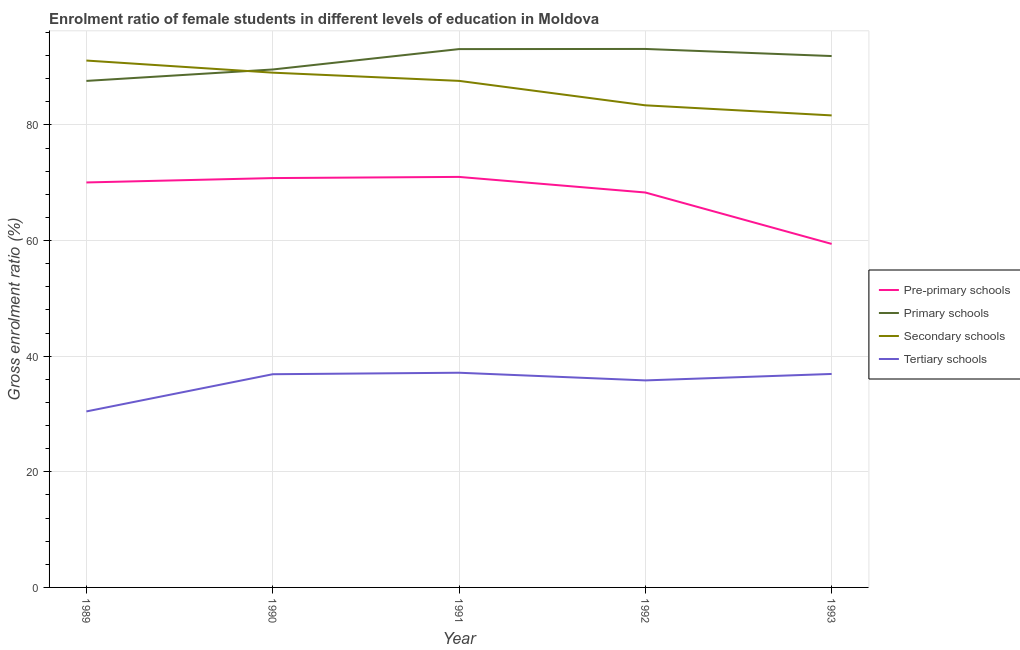How many different coloured lines are there?
Your answer should be compact. 4. Does the line corresponding to gross enrolment ratio(male) in secondary schools intersect with the line corresponding to gross enrolment ratio(male) in tertiary schools?
Offer a very short reply. No. What is the gross enrolment ratio(male) in tertiary schools in 1990?
Ensure brevity in your answer.  36.88. Across all years, what is the maximum gross enrolment ratio(male) in tertiary schools?
Keep it short and to the point. 37.13. Across all years, what is the minimum gross enrolment ratio(male) in secondary schools?
Keep it short and to the point. 81.64. What is the total gross enrolment ratio(male) in secondary schools in the graph?
Your response must be concise. 432.82. What is the difference between the gross enrolment ratio(male) in pre-primary schools in 1989 and that in 1992?
Make the answer very short. 1.74. What is the difference between the gross enrolment ratio(male) in tertiary schools in 1989 and the gross enrolment ratio(male) in secondary schools in 1990?
Your answer should be very brief. -58.6. What is the average gross enrolment ratio(male) in pre-primary schools per year?
Your response must be concise. 67.92. In the year 1992, what is the difference between the gross enrolment ratio(male) in secondary schools and gross enrolment ratio(male) in tertiary schools?
Your response must be concise. 47.58. In how many years, is the gross enrolment ratio(male) in secondary schools greater than 36 %?
Your response must be concise. 5. What is the ratio of the gross enrolment ratio(male) in tertiary schools in 1992 to that in 1993?
Your answer should be very brief. 0.97. Is the gross enrolment ratio(male) in primary schools in 1990 less than that in 1992?
Keep it short and to the point. Yes. Is the difference between the gross enrolment ratio(male) in secondary schools in 1991 and 1993 greater than the difference between the gross enrolment ratio(male) in tertiary schools in 1991 and 1993?
Ensure brevity in your answer.  Yes. What is the difference between the highest and the second highest gross enrolment ratio(male) in secondary schools?
Your answer should be very brief. 2.09. What is the difference between the highest and the lowest gross enrolment ratio(male) in tertiary schools?
Your response must be concise. 6.69. In how many years, is the gross enrolment ratio(male) in tertiary schools greater than the average gross enrolment ratio(male) in tertiary schools taken over all years?
Your answer should be compact. 4. Is it the case that in every year, the sum of the gross enrolment ratio(male) in pre-primary schools and gross enrolment ratio(male) in primary schools is greater than the sum of gross enrolment ratio(male) in secondary schools and gross enrolment ratio(male) in tertiary schools?
Give a very brief answer. Yes. Does the gross enrolment ratio(male) in tertiary schools monotonically increase over the years?
Ensure brevity in your answer.  No. Does the graph contain grids?
Provide a succinct answer. Yes. Where does the legend appear in the graph?
Ensure brevity in your answer.  Center right. How many legend labels are there?
Give a very brief answer. 4. How are the legend labels stacked?
Your answer should be very brief. Vertical. What is the title of the graph?
Offer a very short reply. Enrolment ratio of female students in different levels of education in Moldova. What is the label or title of the X-axis?
Your response must be concise. Year. What is the label or title of the Y-axis?
Give a very brief answer. Gross enrolment ratio (%). What is the Gross enrolment ratio (%) of Pre-primary schools in 1989?
Your response must be concise. 70.05. What is the Gross enrolment ratio (%) in Primary schools in 1989?
Make the answer very short. 87.61. What is the Gross enrolment ratio (%) of Secondary schools in 1989?
Give a very brief answer. 91.13. What is the Gross enrolment ratio (%) in Tertiary schools in 1989?
Offer a very short reply. 30.44. What is the Gross enrolment ratio (%) of Pre-primary schools in 1990?
Your answer should be very brief. 70.8. What is the Gross enrolment ratio (%) of Primary schools in 1990?
Provide a succinct answer. 89.59. What is the Gross enrolment ratio (%) of Secondary schools in 1990?
Provide a short and direct response. 89.04. What is the Gross enrolment ratio (%) in Tertiary schools in 1990?
Ensure brevity in your answer.  36.88. What is the Gross enrolment ratio (%) in Pre-primary schools in 1991?
Provide a short and direct response. 71.01. What is the Gross enrolment ratio (%) in Primary schools in 1991?
Make the answer very short. 93.11. What is the Gross enrolment ratio (%) of Secondary schools in 1991?
Offer a terse response. 87.62. What is the Gross enrolment ratio (%) in Tertiary schools in 1991?
Give a very brief answer. 37.13. What is the Gross enrolment ratio (%) of Pre-primary schools in 1992?
Your answer should be compact. 68.31. What is the Gross enrolment ratio (%) of Primary schools in 1992?
Ensure brevity in your answer.  93.14. What is the Gross enrolment ratio (%) in Secondary schools in 1992?
Your answer should be compact. 83.39. What is the Gross enrolment ratio (%) of Tertiary schools in 1992?
Provide a succinct answer. 35.81. What is the Gross enrolment ratio (%) of Pre-primary schools in 1993?
Provide a succinct answer. 59.42. What is the Gross enrolment ratio (%) of Primary schools in 1993?
Keep it short and to the point. 91.91. What is the Gross enrolment ratio (%) of Secondary schools in 1993?
Your answer should be very brief. 81.64. What is the Gross enrolment ratio (%) in Tertiary schools in 1993?
Ensure brevity in your answer.  36.92. Across all years, what is the maximum Gross enrolment ratio (%) in Pre-primary schools?
Keep it short and to the point. 71.01. Across all years, what is the maximum Gross enrolment ratio (%) in Primary schools?
Provide a short and direct response. 93.14. Across all years, what is the maximum Gross enrolment ratio (%) of Secondary schools?
Your response must be concise. 91.13. Across all years, what is the maximum Gross enrolment ratio (%) of Tertiary schools?
Your answer should be compact. 37.13. Across all years, what is the minimum Gross enrolment ratio (%) in Pre-primary schools?
Offer a very short reply. 59.42. Across all years, what is the minimum Gross enrolment ratio (%) in Primary schools?
Offer a terse response. 87.61. Across all years, what is the minimum Gross enrolment ratio (%) in Secondary schools?
Provide a short and direct response. 81.64. Across all years, what is the minimum Gross enrolment ratio (%) of Tertiary schools?
Ensure brevity in your answer.  30.44. What is the total Gross enrolment ratio (%) of Pre-primary schools in the graph?
Keep it short and to the point. 339.58. What is the total Gross enrolment ratio (%) in Primary schools in the graph?
Offer a terse response. 455.36. What is the total Gross enrolment ratio (%) of Secondary schools in the graph?
Keep it short and to the point. 432.82. What is the total Gross enrolment ratio (%) in Tertiary schools in the graph?
Your answer should be very brief. 177.18. What is the difference between the Gross enrolment ratio (%) of Pre-primary schools in 1989 and that in 1990?
Keep it short and to the point. -0.76. What is the difference between the Gross enrolment ratio (%) of Primary schools in 1989 and that in 1990?
Provide a short and direct response. -1.98. What is the difference between the Gross enrolment ratio (%) in Secondary schools in 1989 and that in 1990?
Give a very brief answer. 2.09. What is the difference between the Gross enrolment ratio (%) in Tertiary schools in 1989 and that in 1990?
Your response must be concise. -6.44. What is the difference between the Gross enrolment ratio (%) of Pre-primary schools in 1989 and that in 1991?
Offer a very short reply. -0.96. What is the difference between the Gross enrolment ratio (%) of Primary schools in 1989 and that in 1991?
Offer a very short reply. -5.5. What is the difference between the Gross enrolment ratio (%) in Secondary schools in 1989 and that in 1991?
Provide a short and direct response. 3.51. What is the difference between the Gross enrolment ratio (%) of Tertiary schools in 1989 and that in 1991?
Provide a short and direct response. -6.69. What is the difference between the Gross enrolment ratio (%) of Pre-primary schools in 1989 and that in 1992?
Keep it short and to the point. 1.74. What is the difference between the Gross enrolment ratio (%) of Primary schools in 1989 and that in 1992?
Offer a very short reply. -5.53. What is the difference between the Gross enrolment ratio (%) in Secondary schools in 1989 and that in 1992?
Make the answer very short. 7.74. What is the difference between the Gross enrolment ratio (%) of Tertiary schools in 1989 and that in 1992?
Your answer should be compact. -5.37. What is the difference between the Gross enrolment ratio (%) of Pre-primary schools in 1989 and that in 1993?
Your answer should be compact. 10.63. What is the difference between the Gross enrolment ratio (%) in Primary schools in 1989 and that in 1993?
Provide a succinct answer. -4.3. What is the difference between the Gross enrolment ratio (%) of Secondary schools in 1989 and that in 1993?
Your answer should be very brief. 9.49. What is the difference between the Gross enrolment ratio (%) in Tertiary schools in 1989 and that in 1993?
Offer a very short reply. -6.48. What is the difference between the Gross enrolment ratio (%) of Pre-primary schools in 1990 and that in 1991?
Offer a very short reply. -0.2. What is the difference between the Gross enrolment ratio (%) of Primary schools in 1990 and that in 1991?
Your answer should be very brief. -3.53. What is the difference between the Gross enrolment ratio (%) of Secondary schools in 1990 and that in 1991?
Offer a terse response. 1.42. What is the difference between the Gross enrolment ratio (%) in Tertiary schools in 1990 and that in 1991?
Your response must be concise. -0.26. What is the difference between the Gross enrolment ratio (%) in Pre-primary schools in 1990 and that in 1992?
Your answer should be very brief. 2.49. What is the difference between the Gross enrolment ratio (%) in Primary schools in 1990 and that in 1992?
Offer a terse response. -3.55. What is the difference between the Gross enrolment ratio (%) in Secondary schools in 1990 and that in 1992?
Your answer should be very brief. 5.65. What is the difference between the Gross enrolment ratio (%) in Tertiary schools in 1990 and that in 1992?
Provide a succinct answer. 1.07. What is the difference between the Gross enrolment ratio (%) in Pre-primary schools in 1990 and that in 1993?
Your answer should be very brief. 11.39. What is the difference between the Gross enrolment ratio (%) in Primary schools in 1990 and that in 1993?
Ensure brevity in your answer.  -2.33. What is the difference between the Gross enrolment ratio (%) in Secondary schools in 1990 and that in 1993?
Your answer should be compact. 7.4. What is the difference between the Gross enrolment ratio (%) of Tertiary schools in 1990 and that in 1993?
Ensure brevity in your answer.  -0.05. What is the difference between the Gross enrolment ratio (%) of Pre-primary schools in 1991 and that in 1992?
Your answer should be very brief. 2.7. What is the difference between the Gross enrolment ratio (%) of Primary schools in 1991 and that in 1992?
Your answer should be compact. -0.02. What is the difference between the Gross enrolment ratio (%) in Secondary schools in 1991 and that in 1992?
Ensure brevity in your answer.  4.23. What is the difference between the Gross enrolment ratio (%) in Tertiary schools in 1991 and that in 1992?
Keep it short and to the point. 1.33. What is the difference between the Gross enrolment ratio (%) of Pre-primary schools in 1991 and that in 1993?
Provide a succinct answer. 11.59. What is the difference between the Gross enrolment ratio (%) of Primary schools in 1991 and that in 1993?
Provide a succinct answer. 1.2. What is the difference between the Gross enrolment ratio (%) in Secondary schools in 1991 and that in 1993?
Your response must be concise. 5.97. What is the difference between the Gross enrolment ratio (%) of Tertiary schools in 1991 and that in 1993?
Offer a very short reply. 0.21. What is the difference between the Gross enrolment ratio (%) of Pre-primary schools in 1992 and that in 1993?
Keep it short and to the point. 8.89. What is the difference between the Gross enrolment ratio (%) of Primary schools in 1992 and that in 1993?
Make the answer very short. 1.23. What is the difference between the Gross enrolment ratio (%) of Secondary schools in 1992 and that in 1993?
Offer a very short reply. 1.75. What is the difference between the Gross enrolment ratio (%) of Tertiary schools in 1992 and that in 1993?
Give a very brief answer. -1.11. What is the difference between the Gross enrolment ratio (%) of Pre-primary schools in 1989 and the Gross enrolment ratio (%) of Primary schools in 1990?
Provide a succinct answer. -19.54. What is the difference between the Gross enrolment ratio (%) of Pre-primary schools in 1989 and the Gross enrolment ratio (%) of Secondary schools in 1990?
Your answer should be very brief. -18.99. What is the difference between the Gross enrolment ratio (%) of Pre-primary schools in 1989 and the Gross enrolment ratio (%) of Tertiary schools in 1990?
Ensure brevity in your answer.  33.17. What is the difference between the Gross enrolment ratio (%) of Primary schools in 1989 and the Gross enrolment ratio (%) of Secondary schools in 1990?
Give a very brief answer. -1.43. What is the difference between the Gross enrolment ratio (%) of Primary schools in 1989 and the Gross enrolment ratio (%) of Tertiary schools in 1990?
Your response must be concise. 50.73. What is the difference between the Gross enrolment ratio (%) in Secondary schools in 1989 and the Gross enrolment ratio (%) in Tertiary schools in 1990?
Offer a terse response. 54.25. What is the difference between the Gross enrolment ratio (%) in Pre-primary schools in 1989 and the Gross enrolment ratio (%) in Primary schools in 1991?
Offer a terse response. -23.07. What is the difference between the Gross enrolment ratio (%) of Pre-primary schools in 1989 and the Gross enrolment ratio (%) of Secondary schools in 1991?
Offer a terse response. -17.57. What is the difference between the Gross enrolment ratio (%) in Pre-primary schools in 1989 and the Gross enrolment ratio (%) in Tertiary schools in 1991?
Ensure brevity in your answer.  32.91. What is the difference between the Gross enrolment ratio (%) in Primary schools in 1989 and the Gross enrolment ratio (%) in Secondary schools in 1991?
Ensure brevity in your answer.  -0.01. What is the difference between the Gross enrolment ratio (%) of Primary schools in 1989 and the Gross enrolment ratio (%) of Tertiary schools in 1991?
Offer a terse response. 50.48. What is the difference between the Gross enrolment ratio (%) of Secondary schools in 1989 and the Gross enrolment ratio (%) of Tertiary schools in 1991?
Ensure brevity in your answer.  54. What is the difference between the Gross enrolment ratio (%) in Pre-primary schools in 1989 and the Gross enrolment ratio (%) in Primary schools in 1992?
Ensure brevity in your answer.  -23.09. What is the difference between the Gross enrolment ratio (%) in Pre-primary schools in 1989 and the Gross enrolment ratio (%) in Secondary schools in 1992?
Make the answer very short. -13.34. What is the difference between the Gross enrolment ratio (%) in Pre-primary schools in 1989 and the Gross enrolment ratio (%) in Tertiary schools in 1992?
Provide a short and direct response. 34.24. What is the difference between the Gross enrolment ratio (%) in Primary schools in 1989 and the Gross enrolment ratio (%) in Secondary schools in 1992?
Your response must be concise. 4.22. What is the difference between the Gross enrolment ratio (%) in Primary schools in 1989 and the Gross enrolment ratio (%) in Tertiary schools in 1992?
Offer a very short reply. 51.8. What is the difference between the Gross enrolment ratio (%) in Secondary schools in 1989 and the Gross enrolment ratio (%) in Tertiary schools in 1992?
Your response must be concise. 55.32. What is the difference between the Gross enrolment ratio (%) of Pre-primary schools in 1989 and the Gross enrolment ratio (%) of Primary schools in 1993?
Your response must be concise. -21.86. What is the difference between the Gross enrolment ratio (%) of Pre-primary schools in 1989 and the Gross enrolment ratio (%) of Secondary schools in 1993?
Offer a very short reply. -11.6. What is the difference between the Gross enrolment ratio (%) in Pre-primary schools in 1989 and the Gross enrolment ratio (%) in Tertiary schools in 1993?
Your answer should be very brief. 33.12. What is the difference between the Gross enrolment ratio (%) in Primary schools in 1989 and the Gross enrolment ratio (%) in Secondary schools in 1993?
Your answer should be compact. 5.97. What is the difference between the Gross enrolment ratio (%) in Primary schools in 1989 and the Gross enrolment ratio (%) in Tertiary schools in 1993?
Keep it short and to the point. 50.69. What is the difference between the Gross enrolment ratio (%) of Secondary schools in 1989 and the Gross enrolment ratio (%) of Tertiary schools in 1993?
Ensure brevity in your answer.  54.21. What is the difference between the Gross enrolment ratio (%) in Pre-primary schools in 1990 and the Gross enrolment ratio (%) in Primary schools in 1991?
Keep it short and to the point. -22.31. What is the difference between the Gross enrolment ratio (%) in Pre-primary schools in 1990 and the Gross enrolment ratio (%) in Secondary schools in 1991?
Your answer should be very brief. -16.81. What is the difference between the Gross enrolment ratio (%) of Pre-primary schools in 1990 and the Gross enrolment ratio (%) of Tertiary schools in 1991?
Offer a terse response. 33.67. What is the difference between the Gross enrolment ratio (%) of Primary schools in 1990 and the Gross enrolment ratio (%) of Secondary schools in 1991?
Make the answer very short. 1.97. What is the difference between the Gross enrolment ratio (%) in Primary schools in 1990 and the Gross enrolment ratio (%) in Tertiary schools in 1991?
Your answer should be very brief. 52.45. What is the difference between the Gross enrolment ratio (%) in Secondary schools in 1990 and the Gross enrolment ratio (%) in Tertiary schools in 1991?
Your answer should be very brief. 51.9. What is the difference between the Gross enrolment ratio (%) in Pre-primary schools in 1990 and the Gross enrolment ratio (%) in Primary schools in 1992?
Offer a terse response. -22.33. What is the difference between the Gross enrolment ratio (%) in Pre-primary schools in 1990 and the Gross enrolment ratio (%) in Secondary schools in 1992?
Your answer should be compact. -12.59. What is the difference between the Gross enrolment ratio (%) in Pre-primary schools in 1990 and the Gross enrolment ratio (%) in Tertiary schools in 1992?
Offer a terse response. 34.99. What is the difference between the Gross enrolment ratio (%) of Primary schools in 1990 and the Gross enrolment ratio (%) of Secondary schools in 1992?
Provide a short and direct response. 6.2. What is the difference between the Gross enrolment ratio (%) of Primary schools in 1990 and the Gross enrolment ratio (%) of Tertiary schools in 1992?
Make the answer very short. 53.78. What is the difference between the Gross enrolment ratio (%) in Secondary schools in 1990 and the Gross enrolment ratio (%) in Tertiary schools in 1992?
Offer a very short reply. 53.23. What is the difference between the Gross enrolment ratio (%) of Pre-primary schools in 1990 and the Gross enrolment ratio (%) of Primary schools in 1993?
Give a very brief answer. -21.11. What is the difference between the Gross enrolment ratio (%) in Pre-primary schools in 1990 and the Gross enrolment ratio (%) in Secondary schools in 1993?
Keep it short and to the point. -10.84. What is the difference between the Gross enrolment ratio (%) in Pre-primary schools in 1990 and the Gross enrolment ratio (%) in Tertiary schools in 1993?
Offer a terse response. 33.88. What is the difference between the Gross enrolment ratio (%) in Primary schools in 1990 and the Gross enrolment ratio (%) in Secondary schools in 1993?
Give a very brief answer. 7.94. What is the difference between the Gross enrolment ratio (%) in Primary schools in 1990 and the Gross enrolment ratio (%) in Tertiary schools in 1993?
Give a very brief answer. 52.66. What is the difference between the Gross enrolment ratio (%) in Secondary schools in 1990 and the Gross enrolment ratio (%) in Tertiary schools in 1993?
Offer a very short reply. 52.12. What is the difference between the Gross enrolment ratio (%) in Pre-primary schools in 1991 and the Gross enrolment ratio (%) in Primary schools in 1992?
Your answer should be very brief. -22.13. What is the difference between the Gross enrolment ratio (%) of Pre-primary schools in 1991 and the Gross enrolment ratio (%) of Secondary schools in 1992?
Provide a succinct answer. -12.38. What is the difference between the Gross enrolment ratio (%) of Pre-primary schools in 1991 and the Gross enrolment ratio (%) of Tertiary schools in 1992?
Offer a very short reply. 35.2. What is the difference between the Gross enrolment ratio (%) of Primary schools in 1991 and the Gross enrolment ratio (%) of Secondary schools in 1992?
Offer a very short reply. 9.72. What is the difference between the Gross enrolment ratio (%) of Primary schools in 1991 and the Gross enrolment ratio (%) of Tertiary schools in 1992?
Provide a succinct answer. 57.3. What is the difference between the Gross enrolment ratio (%) in Secondary schools in 1991 and the Gross enrolment ratio (%) in Tertiary schools in 1992?
Ensure brevity in your answer.  51.81. What is the difference between the Gross enrolment ratio (%) of Pre-primary schools in 1991 and the Gross enrolment ratio (%) of Primary schools in 1993?
Your response must be concise. -20.91. What is the difference between the Gross enrolment ratio (%) in Pre-primary schools in 1991 and the Gross enrolment ratio (%) in Secondary schools in 1993?
Your answer should be very brief. -10.64. What is the difference between the Gross enrolment ratio (%) in Pre-primary schools in 1991 and the Gross enrolment ratio (%) in Tertiary schools in 1993?
Provide a short and direct response. 34.08. What is the difference between the Gross enrolment ratio (%) in Primary schools in 1991 and the Gross enrolment ratio (%) in Secondary schools in 1993?
Provide a short and direct response. 11.47. What is the difference between the Gross enrolment ratio (%) of Primary schools in 1991 and the Gross enrolment ratio (%) of Tertiary schools in 1993?
Your answer should be compact. 56.19. What is the difference between the Gross enrolment ratio (%) of Secondary schools in 1991 and the Gross enrolment ratio (%) of Tertiary schools in 1993?
Keep it short and to the point. 50.69. What is the difference between the Gross enrolment ratio (%) of Pre-primary schools in 1992 and the Gross enrolment ratio (%) of Primary schools in 1993?
Offer a very short reply. -23.6. What is the difference between the Gross enrolment ratio (%) in Pre-primary schools in 1992 and the Gross enrolment ratio (%) in Secondary schools in 1993?
Offer a terse response. -13.33. What is the difference between the Gross enrolment ratio (%) of Pre-primary schools in 1992 and the Gross enrolment ratio (%) of Tertiary schools in 1993?
Make the answer very short. 31.39. What is the difference between the Gross enrolment ratio (%) of Primary schools in 1992 and the Gross enrolment ratio (%) of Secondary schools in 1993?
Keep it short and to the point. 11.5. What is the difference between the Gross enrolment ratio (%) of Primary schools in 1992 and the Gross enrolment ratio (%) of Tertiary schools in 1993?
Offer a terse response. 56.22. What is the difference between the Gross enrolment ratio (%) of Secondary schools in 1992 and the Gross enrolment ratio (%) of Tertiary schools in 1993?
Keep it short and to the point. 46.47. What is the average Gross enrolment ratio (%) of Pre-primary schools per year?
Your answer should be very brief. 67.92. What is the average Gross enrolment ratio (%) of Primary schools per year?
Provide a succinct answer. 91.07. What is the average Gross enrolment ratio (%) of Secondary schools per year?
Offer a terse response. 86.56. What is the average Gross enrolment ratio (%) of Tertiary schools per year?
Provide a succinct answer. 35.44. In the year 1989, what is the difference between the Gross enrolment ratio (%) in Pre-primary schools and Gross enrolment ratio (%) in Primary schools?
Provide a short and direct response. -17.56. In the year 1989, what is the difference between the Gross enrolment ratio (%) in Pre-primary schools and Gross enrolment ratio (%) in Secondary schools?
Provide a short and direct response. -21.08. In the year 1989, what is the difference between the Gross enrolment ratio (%) in Pre-primary schools and Gross enrolment ratio (%) in Tertiary schools?
Your response must be concise. 39.61. In the year 1989, what is the difference between the Gross enrolment ratio (%) in Primary schools and Gross enrolment ratio (%) in Secondary schools?
Your answer should be very brief. -3.52. In the year 1989, what is the difference between the Gross enrolment ratio (%) in Primary schools and Gross enrolment ratio (%) in Tertiary schools?
Keep it short and to the point. 57.17. In the year 1989, what is the difference between the Gross enrolment ratio (%) in Secondary schools and Gross enrolment ratio (%) in Tertiary schools?
Provide a short and direct response. 60.69. In the year 1990, what is the difference between the Gross enrolment ratio (%) in Pre-primary schools and Gross enrolment ratio (%) in Primary schools?
Your response must be concise. -18.78. In the year 1990, what is the difference between the Gross enrolment ratio (%) in Pre-primary schools and Gross enrolment ratio (%) in Secondary schools?
Provide a short and direct response. -18.23. In the year 1990, what is the difference between the Gross enrolment ratio (%) of Pre-primary schools and Gross enrolment ratio (%) of Tertiary schools?
Make the answer very short. 33.93. In the year 1990, what is the difference between the Gross enrolment ratio (%) of Primary schools and Gross enrolment ratio (%) of Secondary schools?
Ensure brevity in your answer.  0.55. In the year 1990, what is the difference between the Gross enrolment ratio (%) of Primary schools and Gross enrolment ratio (%) of Tertiary schools?
Provide a succinct answer. 52.71. In the year 1990, what is the difference between the Gross enrolment ratio (%) of Secondary schools and Gross enrolment ratio (%) of Tertiary schools?
Keep it short and to the point. 52.16. In the year 1991, what is the difference between the Gross enrolment ratio (%) in Pre-primary schools and Gross enrolment ratio (%) in Primary schools?
Provide a succinct answer. -22.11. In the year 1991, what is the difference between the Gross enrolment ratio (%) in Pre-primary schools and Gross enrolment ratio (%) in Secondary schools?
Offer a terse response. -16.61. In the year 1991, what is the difference between the Gross enrolment ratio (%) of Pre-primary schools and Gross enrolment ratio (%) of Tertiary schools?
Your answer should be very brief. 33.87. In the year 1991, what is the difference between the Gross enrolment ratio (%) in Primary schools and Gross enrolment ratio (%) in Secondary schools?
Keep it short and to the point. 5.5. In the year 1991, what is the difference between the Gross enrolment ratio (%) in Primary schools and Gross enrolment ratio (%) in Tertiary schools?
Your answer should be compact. 55.98. In the year 1991, what is the difference between the Gross enrolment ratio (%) of Secondary schools and Gross enrolment ratio (%) of Tertiary schools?
Offer a terse response. 50.48. In the year 1992, what is the difference between the Gross enrolment ratio (%) of Pre-primary schools and Gross enrolment ratio (%) of Primary schools?
Keep it short and to the point. -24.83. In the year 1992, what is the difference between the Gross enrolment ratio (%) in Pre-primary schools and Gross enrolment ratio (%) in Secondary schools?
Offer a very short reply. -15.08. In the year 1992, what is the difference between the Gross enrolment ratio (%) in Pre-primary schools and Gross enrolment ratio (%) in Tertiary schools?
Make the answer very short. 32.5. In the year 1992, what is the difference between the Gross enrolment ratio (%) in Primary schools and Gross enrolment ratio (%) in Secondary schools?
Your answer should be very brief. 9.75. In the year 1992, what is the difference between the Gross enrolment ratio (%) in Primary schools and Gross enrolment ratio (%) in Tertiary schools?
Offer a terse response. 57.33. In the year 1992, what is the difference between the Gross enrolment ratio (%) in Secondary schools and Gross enrolment ratio (%) in Tertiary schools?
Your answer should be compact. 47.58. In the year 1993, what is the difference between the Gross enrolment ratio (%) of Pre-primary schools and Gross enrolment ratio (%) of Primary schools?
Make the answer very short. -32.5. In the year 1993, what is the difference between the Gross enrolment ratio (%) of Pre-primary schools and Gross enrolment ratio (%) of Secondary schools?
Provide a succinct answer. -22.23. In the year 1993, what is the difference between the Gross enrolment ratio (%) of Pre-primary schools and Gross enrolment ratio (%) of Tertiary schools?
Keep it short and to the point. 22.49. In the year 1993, what is the difference between the Gross enrolment ratio (%) of Primary schools and Gross enrolment ratio (%) of Secondary schools?
Provide a succinct answer. 10.27. In the year 1993, what is the difference between the Gross enrolment ratio (%) of Primary schools and Gross enrolment ratio (%) of Tertiary schools?
Ensure brevity in your answer.  54.99. In the year 1993, what is the difference between the Gross enrolment ratio (%) in Secondary schools and Gross enrolment ratio (%) in Tertiary schools?
Offer a very short reply. 44.72. What is the ratio of the Gross enrolment ratio (%) in Pre-primary schools in 1989 to that in 1990?
Offer a very short reply. 0.99. What is the ratio of the Gross enrolment ratio (%) in Primary schools in 1989 to that in 1990?
Make the answer very short. 0.98. What is the ratio of the Gross enrolment ratio (%) in Secondary schools in 1989 to that in 1990?
Give a very brief answer. 1.02. What is the ratio of the Gross enrolment ratio (%) of Tertiary schools in 1989 to that in 1990?
Ensure brevity in your answer.  0.83. What is the ratio of the Gross enrolment ratio (%) of Pre-primary schools in 1989 to that in 1991?
Your answer should be very brief. 0.99. What is the ratio of the Gross enrolment ratio (%) in Primary schools in 1989 to that in 1991?
Your answer should be compact. 0.94. What is the ratio of the Gross enrolment ratio (%) in Secondary schools in 1989 to that in 1991?
Provide a succinct answer. 1.04. What is the ratio of the Gross enrolment ratio (%) of Tertiary schools in 1989 to that in 1991?
Keep it short and to the point. 0.82. What is the ratio of the Gross enrolment ratio (%) of Pre-primary schools in 1989 to that in 1992?
Your answer should be compact. 1.03. What is the ratio of the Gross enrolment ratio (%) of Primary schools in 1989 to that in 1992?
Your response must be concise. 0.94. What is the ratio of the Gross enrolment ratio (%) in Secondary schools in 1989 to that in 1992?
Keep it short and to the point. 1.09. What is the ratio of the Gross enrolment ratio (%) of Tertiary schools in 1989 to that in 1992?
Your answer should be very brief. 0.85. What is the ratio of the Gross enrolment ratio (%) of Pre-primary schools in 1989 to that in 1993?
Make the answer very short. 1.18. What is the ratio of the Gross enrolment ratio (%) of Primary schools in 1989 to that in 1993?
Give a very brief answer. 0.95. What is the ratio of the Gross enrolment ratio (%) of Secondary schools in 1989 to that in 1993?
Your answer should be compact. 1.12. What is the ratio of the Gross enrolment ratio (%) of Tertiary schools in 1989 to that in 1993?
Keep it short and to the point. 0.82. What is the ratio of the Gross enrolment ratio (%) in Primary schools in 1990 to that in 1991?
Give a very brief answer. 0.96. What is the ratio of the Gross enrolment ratio (%) in Secondary schools in 1990 to that in 1991?
Your answer should be very brief. 1.02. What is the ratio of the Gross enrolment ratio (%) in Tertiary schools in 1990 to that in 1991?
Provide a succinct answer. 0.99. What is the ratio of the Gross enrolment ratio (%) of Pre-primary schools in 1990 to that in 1992?
Provide a short and direct response. 1.04. What is the ratio of the Gross enrolment ratio (%) in Primary schools in 1990 to that in 1992?
Keep it short and to the point. 0.96. What is the ratio of the Gross enrolment ratio (%) in Secondary schools in 1990 to that in 1992?
Offer a very short reply. 1.07. What is the ratio of the Gross enrolment ratio (%) in Tertiary schools in 1990 to that in 1992?
Give a very brief answer. 1.03. What is the ratio of the Gross enrolment ratio (%) in Pre-primary schools in 1990 to that in 1993?
Offer a terse response. 1.19. What is the ratio of the Gross enrolment ratio (%) of Primary schools in 1990 to that in 1993?
Your response must be concise. 0.97. What is the ratio of the Gross enrolment ratio (%) of Secondary schools in 1990 to that in 1993?
Provide a succinct answer. 1.09. What is the ratio of the Gross enrolment ratio (%) of Pre-primary schools in 1991 to that in 1992?
Your answer should be very brief. 1.04. What is the ratio of the Gross enrolment ratio (%) in Primary schools in 1991 to that in 1992?
Offer a very short reply. 1. What is the ratio of the Gross enrolment ratio (%) in Secondary schools in 1991 to that in 1992?
Your answer should be compact. 1.05. What is the ratio of the Gross enrolment ratio (%) in Pre-primary schools in 1991 to that in 1993?
Offer a terse response. 1.2. What is the ratio of the Gross enrolment ratio (%) in Primary schools in 1991 to that in 1993?
Make the answer very short. 1.01. What is the ratio of the Gross enrolment ratio (%) of Secondary schools in 1991 to that in 1993?
Give a very brief answer. 1.07. What is the ratio of the Gross enrolment ratio (%) of Tertiary schools in 1991 to that in 1993?
Make the answer very short. 1.01. What is the ratio of the Gross enrolment ratio (%) of Pre-primary schools in 1992 to that in 1993?
Provide a succinct answer. 1.15. What is the ratio of the Gross enrolment ratio (%) of Primary schools in 1992 to that in 1993?
Make the answer very short. 1.01. What is the ratio of the Gross enrolment ratio (%) in Secondary schools in 1992 to that in 1993?
Your answer should be very brief. 1.02. What is the ratio of the Gross enrolment ratio (%) in Tertiary schools in 1992 to that in 1993?
Offer a very short reply. 0.97. What is the difference between the highest and the second highest Gross enrolment ratio (%) in Pre-primary schools?
Ensure brevity in your answer.  0.2. What is the difference between the highest and the second highest Gross enrolment ratio (%) of Primary schools?
Your answer should be compact. 0.02. What is the difference between the highest and the second highest Gross enrolment ratio (%) of Secondary schools?
Your answer should be compact. 2.09. What is the difference between the highest and the second highest Gross enrolment ratio (%) in Tertiary schools?
Keep it short and to the point. 0.21. What is the difference between the highest and the lowest Gross enrolment ratio (%) in Pre-primary schools?
Offer a terse response. 11.59. What is the difference between the highest and the lowest Gross enrolment ratio (%) in Primary schools?
Ensure brevity in your answer.  5.53. What is the difference between the highest and the lowest Gross enrolment ratio (%) in Secondary schools?
Make the answer very short. 9.49. What is the difference between the highest and the lowest Gross enrolment ratio (%) of Tertiary schools?
Keep it short and to the point. 6.69. 